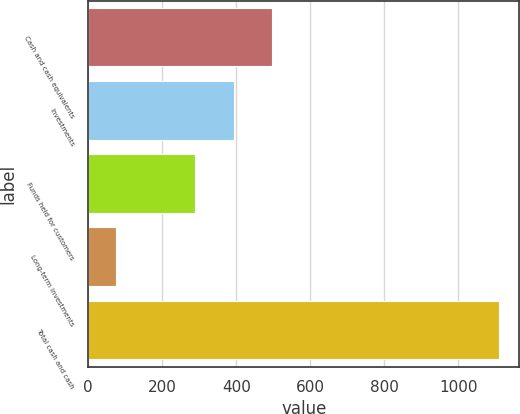<chart> <loc_0><loc_0><loc_500><loc_500><bar_chart><fcel>Cash and cash equivalents<fcel>Investments<fcel>Funds held for customers<fcel>Long-term investments<fcel>Total cash and cash<nl><fcel>496.8<fcel>393.4<fcel>290<fcel>75<fcel>1109<nl></chart> 